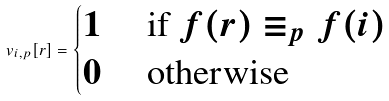<formula> <loc_0><loc_0><loc_500><loc_500>v _ { i , p } [ r ] = \begin{cases} 1 & \text { if } f ( r ) \equiv _ { p } f ( i ) \\ 0 & \text { otherwise } \end{cases}</formula> 